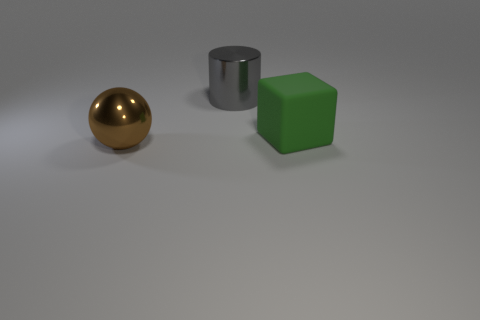Add 2 cylinders. How many objects exist? 5 Subtract all cylinders. How many objects are left? 2 Subtract all gray matte cylinders. Subtract all brown balls. How many objects are left? 2 Add 1 big green rubber blocks. How many big green rubber blocks are left? 2 Add 2 cyan metallic cylinders. How many cyan metallic cylinders exist? 2 Subtract 0 yellow cylinders. How many objects are left? 3 